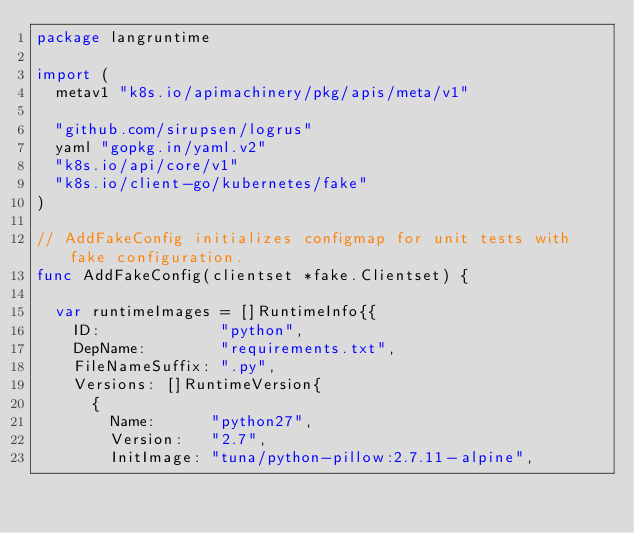<code> <loc_0><loc_0><loc_500><loc_500><_Go_>package langruntime

import (
	metav1 "k8s.io/apimachinery/pkg/apis/meta/v1"

	"github.com/sirupsen/logrus"
	yaml "gopkg.in/yaml.v2"
	"k8s.io/api/core/v1"
	"k8s.io/client-go/kubernetes/fake"
)

// AddFakeConfig initializes configmap for unit tests with fake configuration.
func AddFakeConfig(clientset *fake.Clientset) {

	var runtimeImages = []RuntimeInfo{{
		ID:             "python",
		DepName:        "requirements.txt",
		FileNameSuffix: ".py",
		Versions: []RuntimeVersion{
			{
				Name:      "python27",
				Version:   "2.7",
				InitImage: "tuna/python-pillow:2.7.11-alpine",</code> 